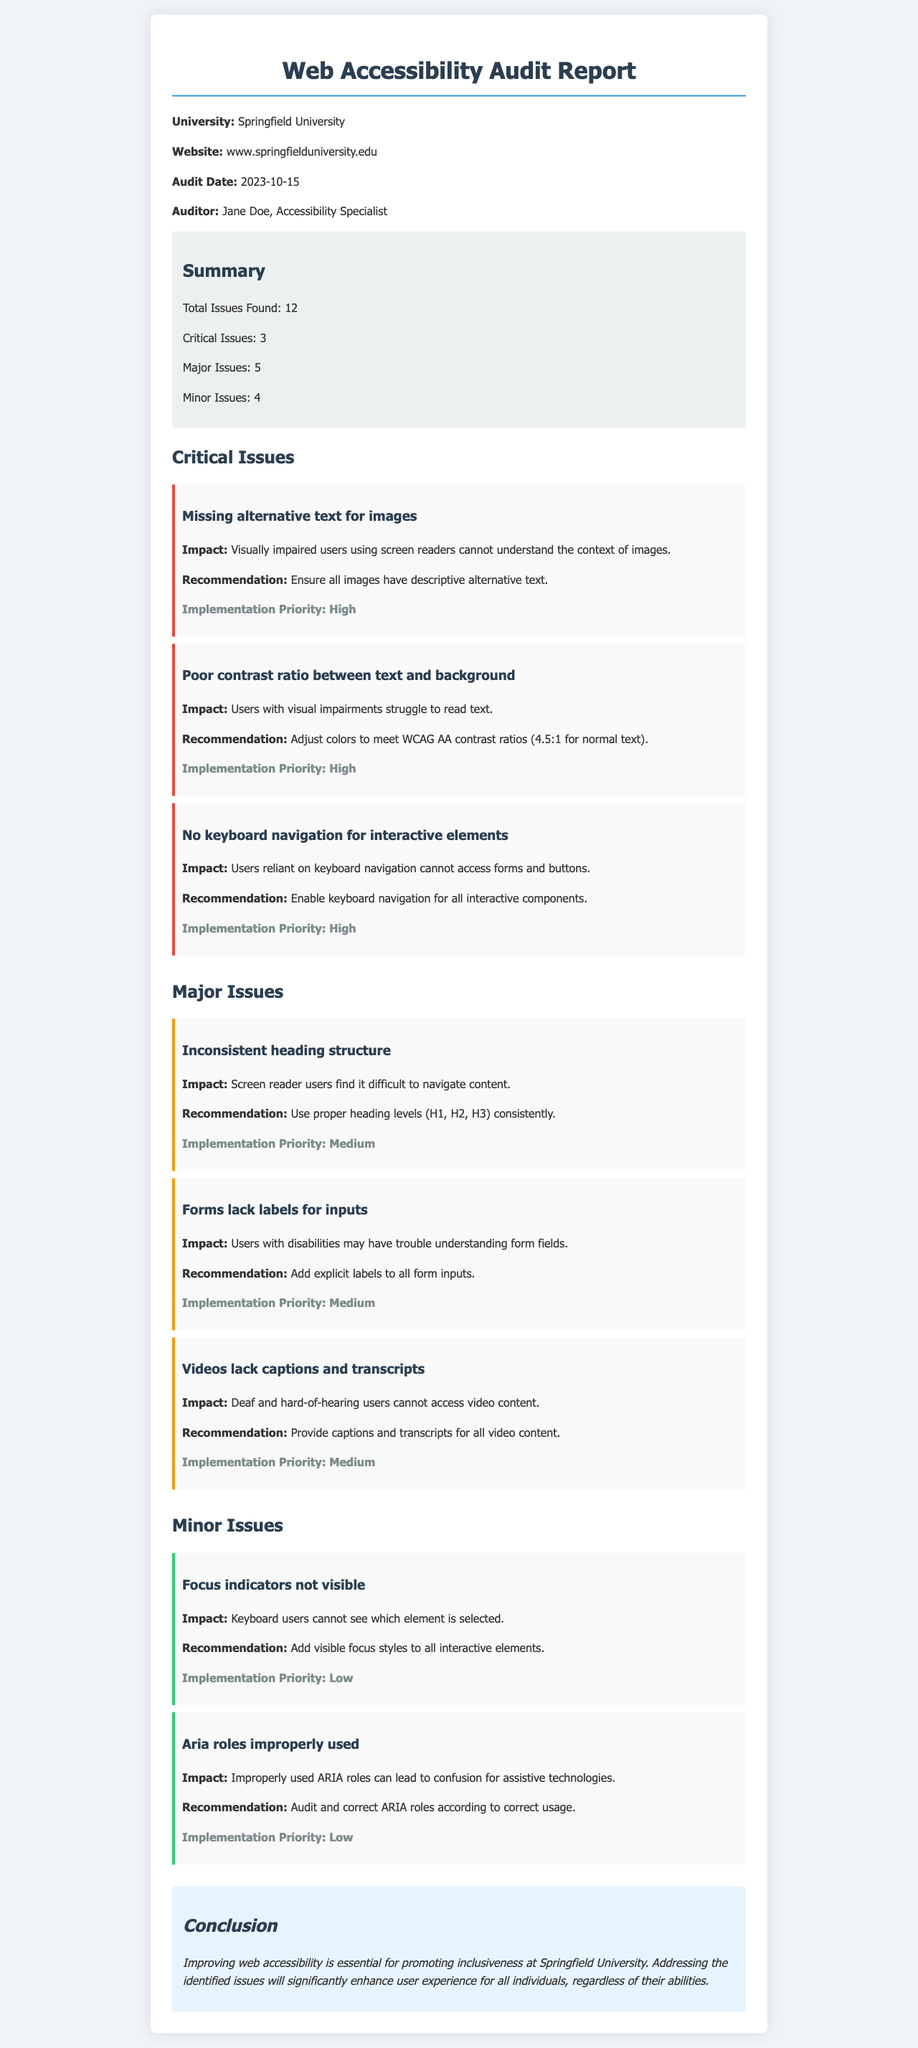What is the university's name? The university's name is stated as Springfield University in the document.
Answer: Springfield University How many total issues were found? The document lists the total issues found as 12.
Answer: 12 What is the priority level for "Missing alternative text for images"? This issue is labeled with a high implementation priority in the report.
Answer: High How many major issues are identified? The report defines five major issues related to web accessibility.
Answer: 5 What is the impact of poor contrast ratio? The document explains that users with visual impairments struggle to read text due to this issue.
Answer: Users with visual impairments struggle to read text What does the conclusion emphasize? The conclusion highlights the importance of improving web accessibility for inclusiveness and user experience.
Answer: Inclusiveness and user experience What recommendation is given for videos? The document suggests providing captions and transcripts for all video content as a recommendation.
Answer: Provide captions and transcripts for all video content Who conducted the audit? The document identifies Jane Doe as the accessibility specialist who conducted the audit.
Answer: Jane Doe What color indicates a critical issue in the document? The color red (specifically #e74c3c) is used for the border of critical issues to highlight them.
Answer: Red 